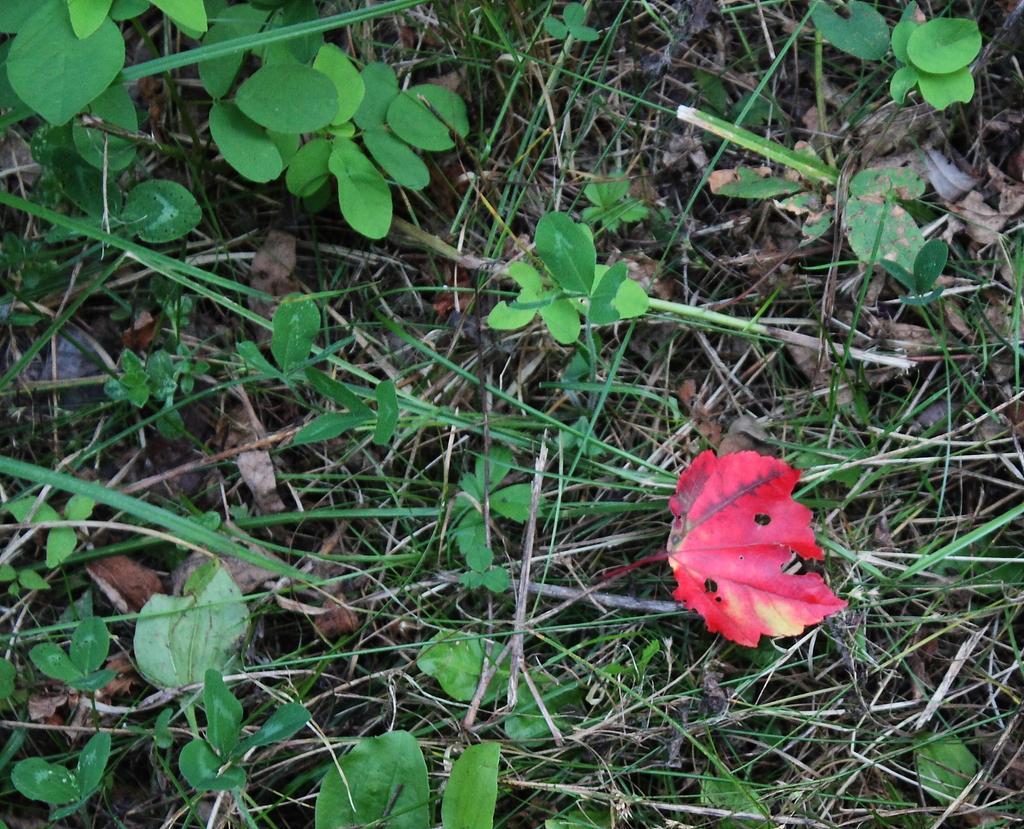Could you give a brief overview of what you see in this image? In the image in the center we can see plants,thin sticks,dry leaves and one red leaf. 